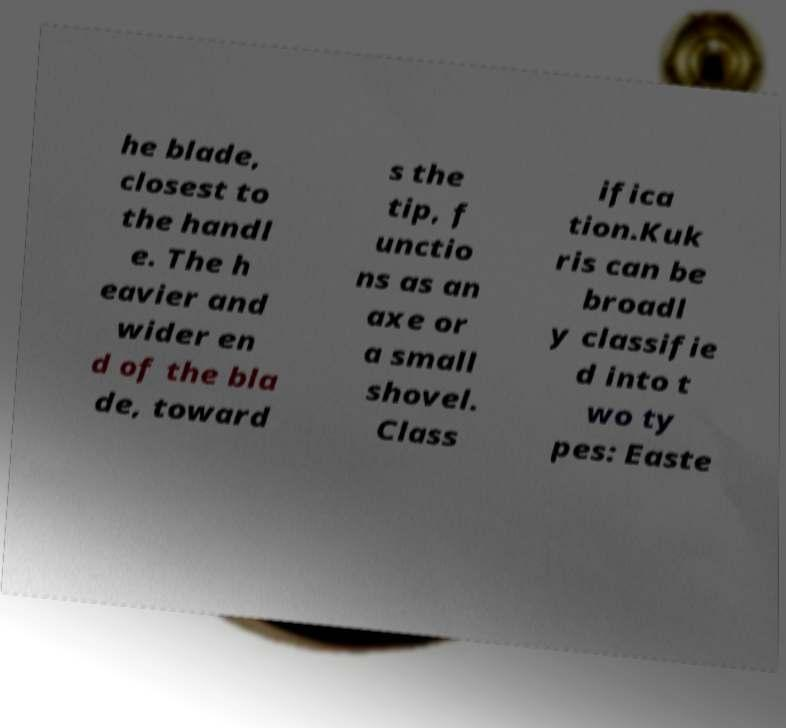Could you extract and type out the text from this image? he blade, closest to the handl e. The h eavier and wider en d of the bla de, toward s the tip, f unctio ns as an axe or a small shovel. Class ifica tion.Kuk ris can be broadl y classifie d into t wo ty pes: Easte 